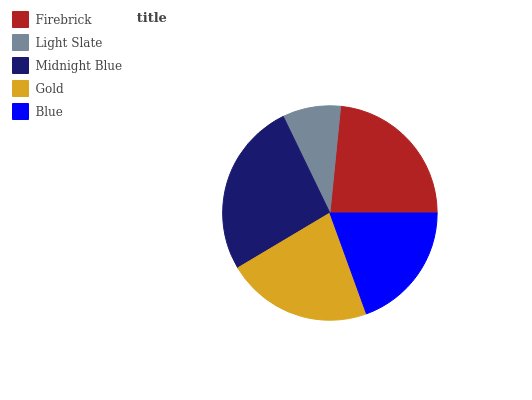Is Light Slate the minimum?
Answer yes or no. Yes. Is Midnight Blue the maximum?
Answer yes or no. Yes. Is Midnight Blue the minimum?
Answer yes or no. No. Is Light Slate the maximum?
Answer yes or no. No. Is Midnight Blue greater than Light Slate?
Answer yes or no. Yes. Is Light Slate less than Midnight Blue?
Answer yes or no. Yes. Is Light Slate greater than Midnight Blue?
Answer yes or no. No. Is Midnight Blue less than Light Slate?
Answer yes or no. No. Is Gold the high median?
Answer yes or no. Yes. Is Gold the low median?
Answer yes or no. Yes. Is Light Slate the high median?
Answer yes or no. No. Is Midnight Blue the low median?
Answer yes or no. No. 